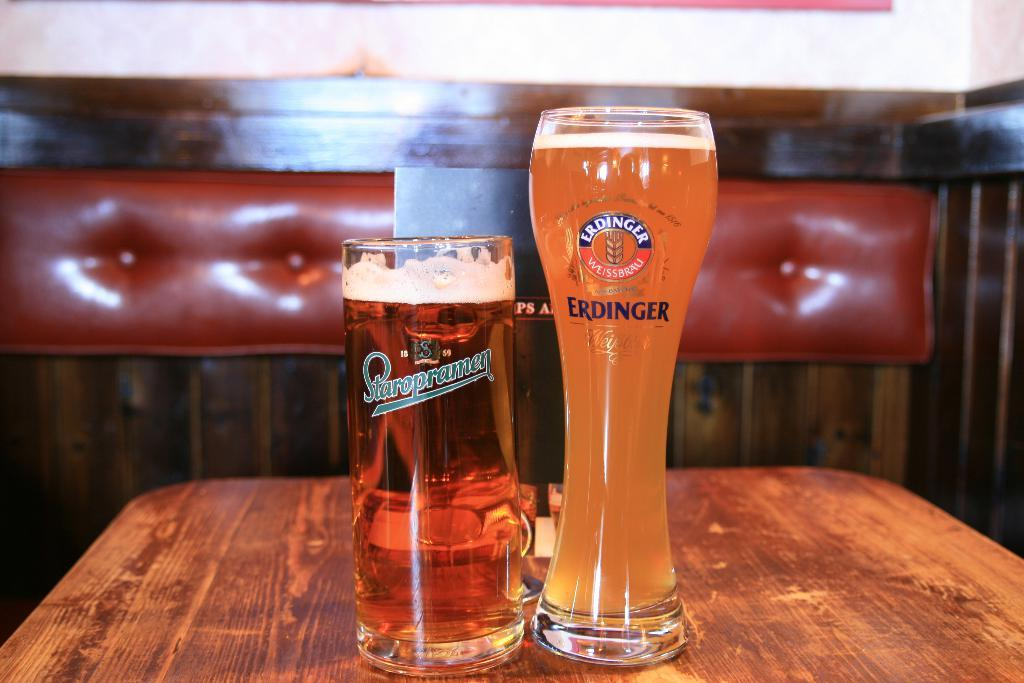Provide a one-sentence caption for the provided image. 2 beers in different sized containers by Staropramen and Erdinger. 